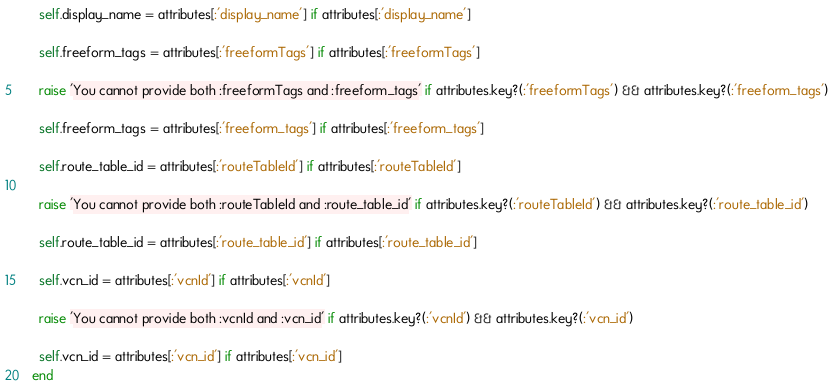Convert code to text. <code><loc_0><loc_0><loc_500><loc_500><_Ruby_>
      self.display_name = attributes[:'display_name'] if attributes[:'display_name']

      self.freeform_tags = attributes[:'freeformTags'] if attributes[:'freeformTags']

      raise 'You cannot provide both :freeformTags and :freeform_tags' if attributes.key?(:'freeformTags') && attributes.key?(:'freeform_tags')

      self.freeform_tags = attributes[:'freeform_tags'] if attributes[:'freeform_tags']

      self.route_table_id = attributes[:'routeTableId'] if attributes[:'routeTableId']

      raise 'You cannot provide both :routeTableId and :route_table_id' if attributes.key?(:'routeTableId') && attributes.key?(:'route_table_id')

      self.route_table_id = attributes[:'route_table_id'] if attributes[:'route_table_id']

      self.vcn_id = attributes[:'vcnId'] if attributes[:'vcnId']

      raise 'You cannot provide both :vcnId and :vcn_id' if attributes.key?(:'vcnId') && attributes.key?(:'vcn_id')

      self.vcn_id = attributes[:'vcn_id'] if attributes[:'vcn_id']
    end</code> 